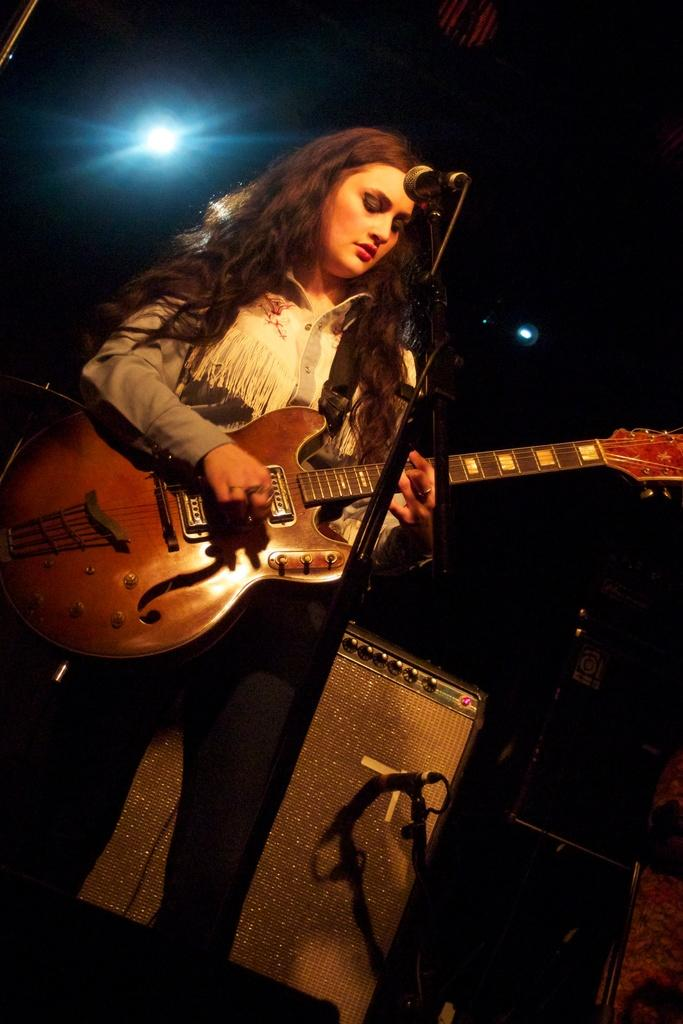Who is the main subject in the image? There is a lady in the image. What is the lady holding in the image? The lady is holding a guitar. What is the lady doing with the guitar? The lady is playing the guitar. What is in front of the lady? There is a microphone in front of the lady. What can be seen behind the lady? There are musical instruments behind the lady. What can be seen in the image that provides light? There is a light visible in the image. How does the lady's digestion process affect the sound of the guitar in the image? The lady's digestion process is not visible or relevant in the image, so it cannot affect the sound of the guitar. 